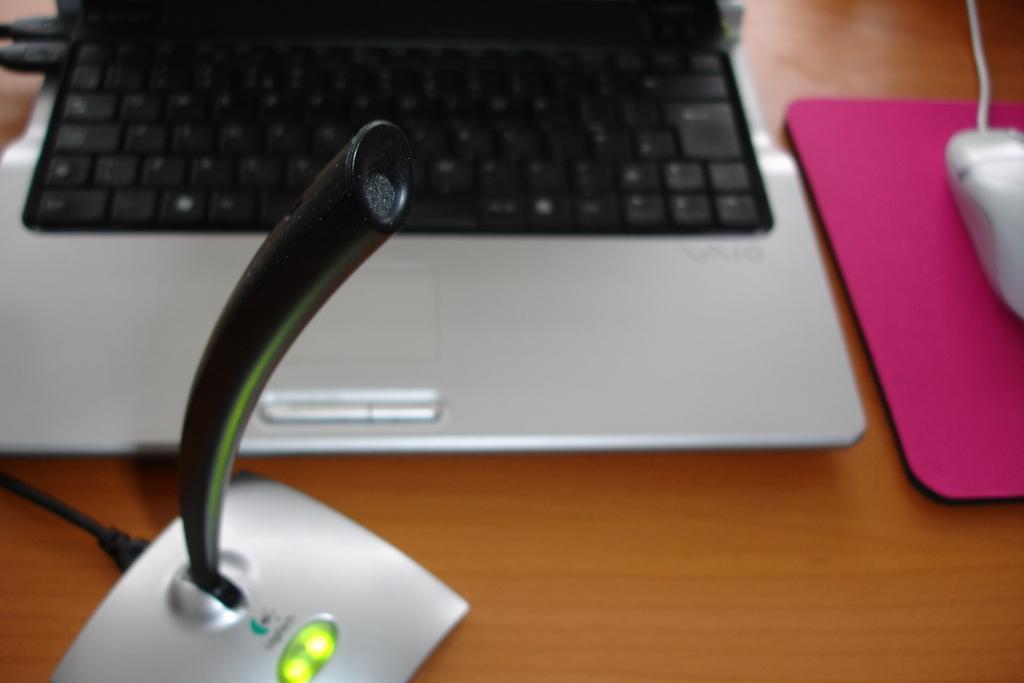How would you summarize this image in a sentence or two? In the image we can see table. On table,there is a laptop and mouse. 